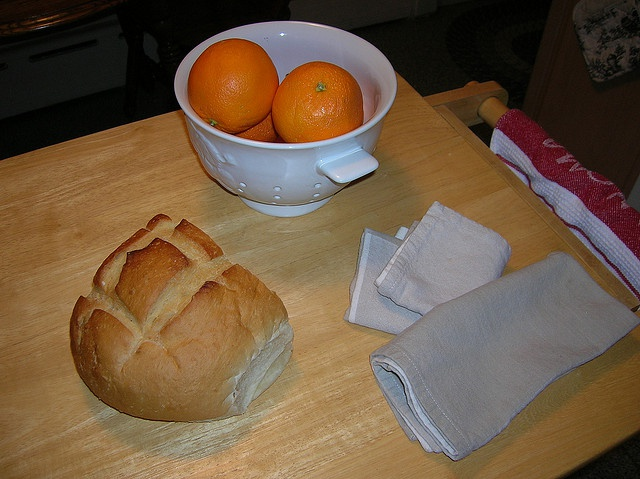Describe the objects in this image and their specific colors. I can see dining table in black, olive, and tan tones, bowl in black, gray, red, and maroon tones, orange in black, brown, maroon, and red tones, orange in black, red, and maroon tones, and orange in black, maroon, and brown tones in this image. 